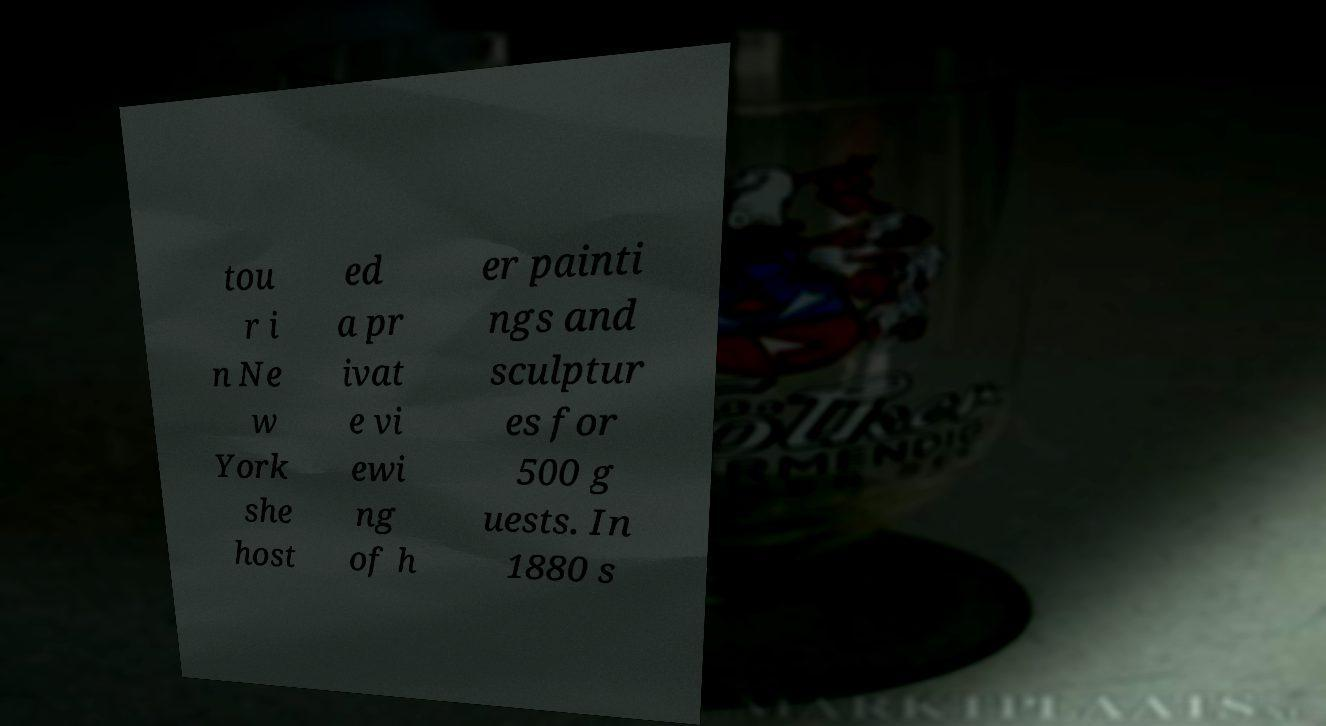Please identify and transcribe the text found in this image. tou r i n Ne w York she host ed a pr ivat e vi ewi ng of h er painti ngs and sculptur es for 500 g uests. In 1880 s 